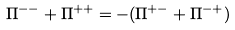<formula> <loc_0><loc_0><loc_500><loc_500>\Pi ^ { - - } + \Pi ^ { + + } = - ( \Pi ^ { + - } + \Pi ^ { - + } )</formula> 